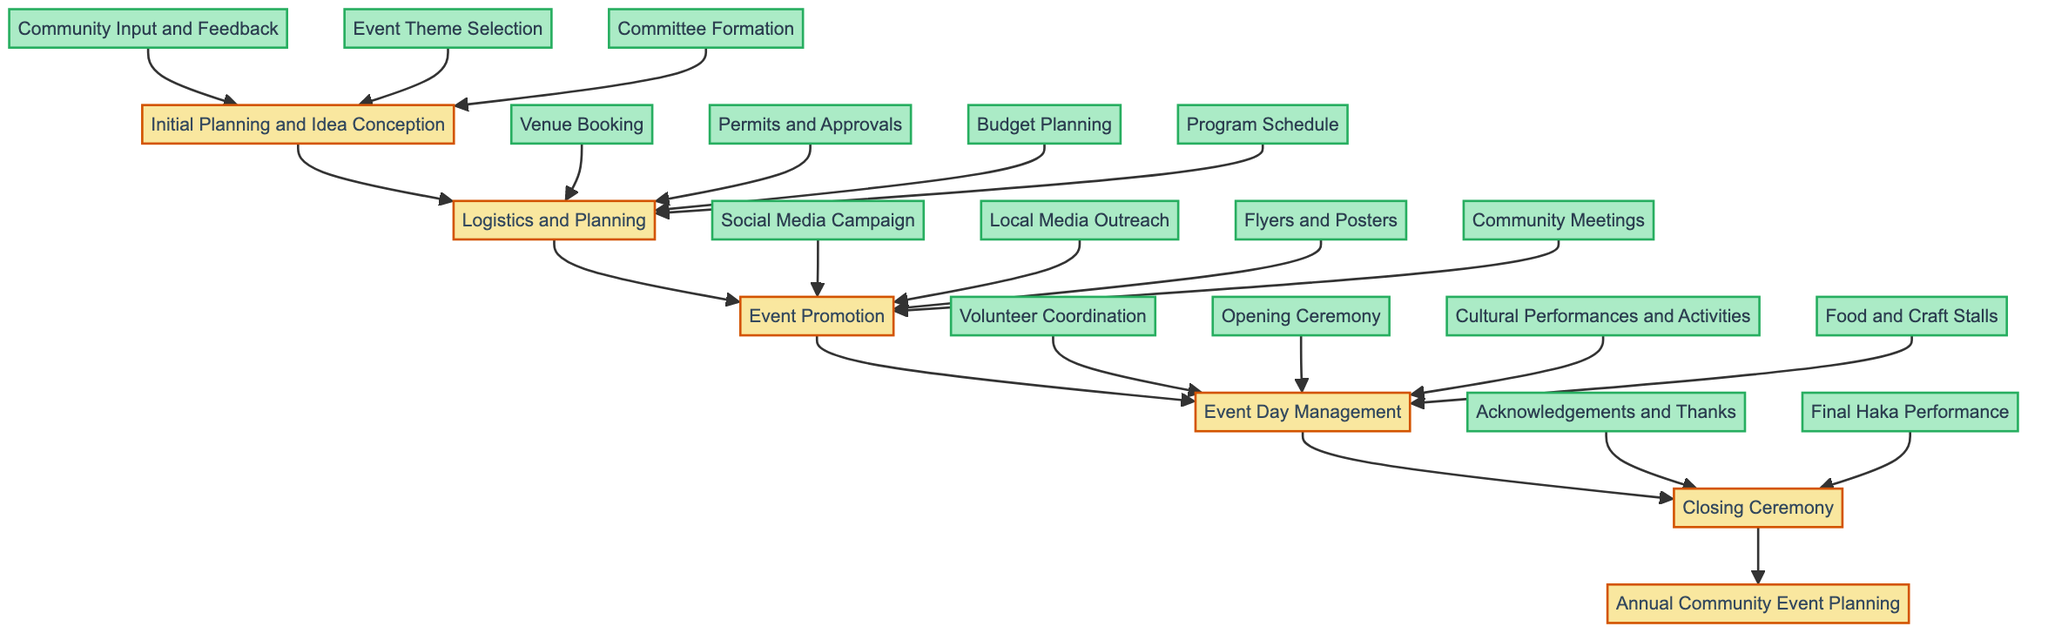What is the top node in the flow chart? The top node represents the overall process of the event planning, which is "Annual Community Event Planning."
Answer: Annual Community Event Planning How many main phases are there in the planning process? There are five main phases indicated in the diagram: Initial Planning and Idea Conception, Logistics and Planning, Event Promotion, Event Day Management, and Closing Ceremony.
Answer: Five Which phase comes directly after Event Promotion? The phase that comes directly after Event Promotion is Event Day Management.
Answer: Event Day Management What are the two components included in the Closing Ceremony? The components involved in the Closing Ceremony are "Acknowledgements and Thanks" and "Final Haka Performance."
Answer: Acknowledgements and Thanks, Final Haka Performance Which sub-process falls under Event Day Management that involves starting the event? The sub-process that starts the event and is included under Event Day Management is "Opening Ceremony."
Answer: Opening Ceremony How many sub-processes are involved in the Logistics and Planning phase? There are four sub-processes involved in the Logistics and Planning phase: Venue Booking, Permits and Approvals, Budget Planning, and Program Schedule.
Answer: Four What is the relationship between 'Community Input and Feedback' and 'Committee Formation'? Both 'Community Input and Feedback' and 'Committee Formation' are sub-processes that fall under the initial planning phase.
Answer: They are both sub-processes of Initial Planning and Idea Conception What is the last phase that is executed in the flow? The last phase executed in the flow is the "Closing Ceremony."
Answer: Closing Ceremony What is the first sub-process in the Event Promotion phase? The first sub-process in the Event Promotion phase is "Social Media Campaign."
Answer: Social Media Campaign 